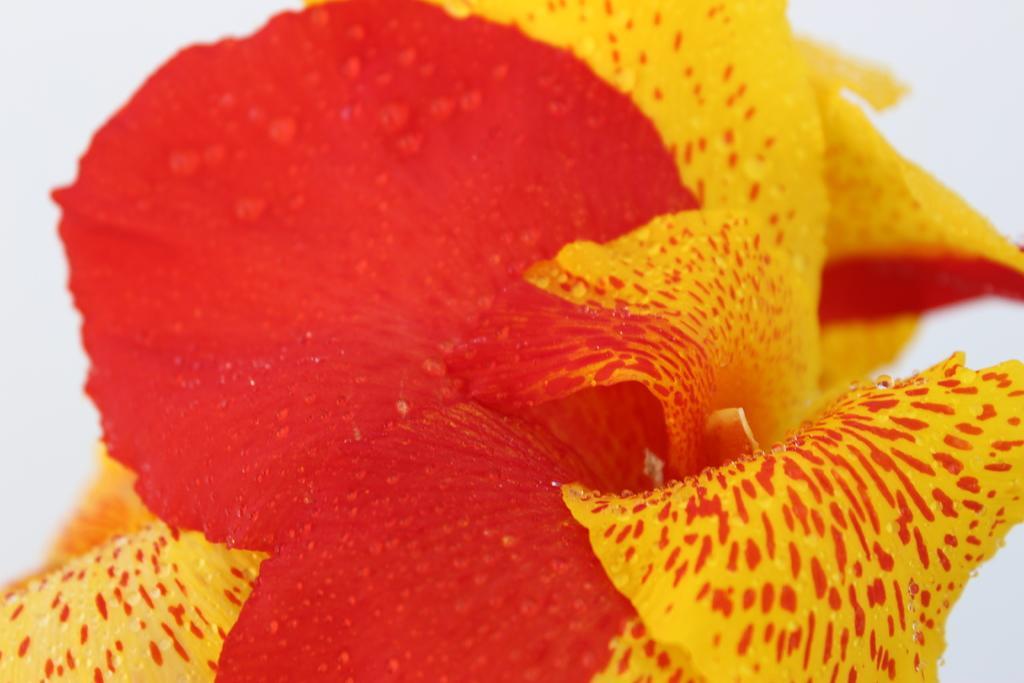Can you describe this image briefly? This picture contains flower. This flower is in red and yellow color. In the background, it is white in color. 